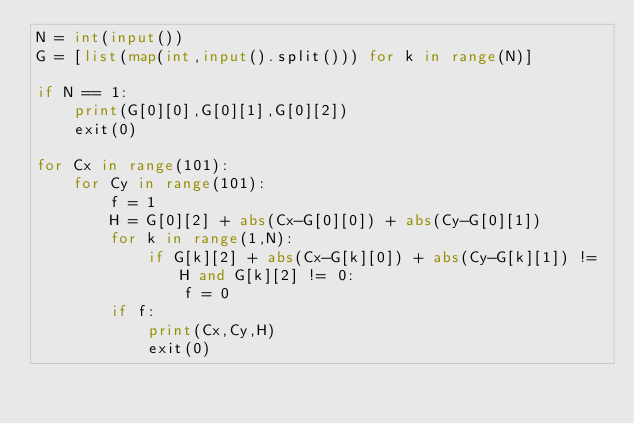<code> <loc_0><loc_0><loc_500><loc_500><_Python_>N = int(input())
G = [list(map(int,input().split())) for k in range(N)]

if N == 1:
    print(G[0][0],G[0][1],G[0][2])
    exit(0)

for Cx in range(101):
    for Cy in range(101):
        f = 1
        H = G[0][2] + abs(Cx-G[0][0]) + abs(Cy-G[0][1])
        for k in range(1,N):
            if G[k][2] + abs(Cx-G[k][0]) + abs(Cy-G[k][1]) != H and G[k][2] != 0:
                f = 0
        if f:
            print(Cx,Cy,H)
            exit(0)
</code> 